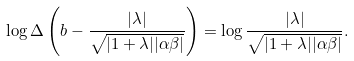Convert formula to latex. <formula><loc_0><loc_0><loc_500><loc_500>\log \Delta \left ( b - \frac { | \lambda | } { \sqrt { | 1 + \lambda | | \alpha \beta | } } \right ) = \log \frac { | \lambda | } { \sqrt { | 1 + \lambda | | \alpha \beta | } } .</formula> 